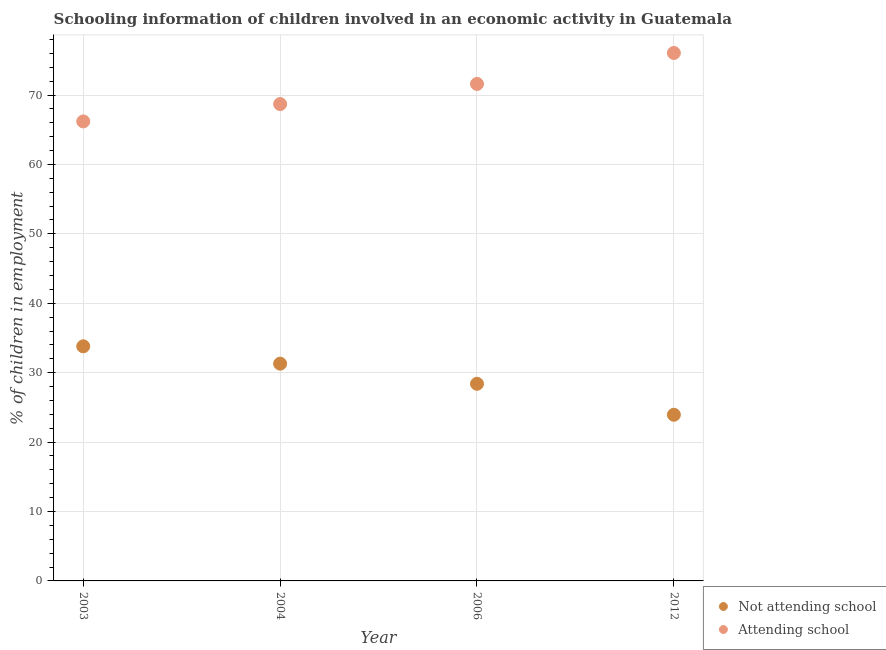How many different coloured dotlines are there?
Your answer should be compact. 2. Is the number of dotlines equal to the number of legend labels?
Keep it short and to the point. Yes. What is the percentage of employed children who are attending school in 2006?
Make the answer very short. 71.6. Across all years, what is the maximum percentage of employed children who are attending school?
Your answer should be compact. 76.06. Across all years, what is the minimum percentage of employed children who are attending school?
Your answer should be very brief. 66.2. In which year was the percentage of employed children who are attending school maximum?
Ensure brevity in your answer.  2012. What is the total percentage of employed children who are attending school in the graph?
Your response must be concise. 282.56. What is the difference between the percentage of employed children who are attending school in 2006 and the percentage of employed children who are not attending school in 2012?
Provide a short and direct response. 47.66. What is the average percentage of employed children who are attending school per year?
Make the answer very short. 70.64. In the year 2006, what is the difference between the percentage of employed children who are not attending school and percentage of employed children who are attending school?
Your answer should be very brief. -43.2. What is the ratio of the percentage of employed children who are attending school in 2003 to that in 2006?
Provide a short and direct response. 0.92. Is the percentage of employed children who are attending school in 2003 less than that in 2012?
Provide a short and direct response. Yes. Is the difference between the percentage of employed children who are not attending school in 2004 and 2012 greater than the difference between the percentage of employed children who are attending school in 2004 and 2012?
Offer a terse response. Yes. What is the difference between the highest and the second highest percentage of employed children who are not attending school?
Your response must be concise. 2.5. What is the difference between the highest and the lowest percentage of employed children who are attending school?
Your answer should be very brief. 9.86. In how many years, is the percentage of employed children who are not attending school greater than the average percentage of employed children who are not attending school taken over all years?
Provide a short and direct response. 2. Does the percentage of employed children who are attending school monotonically increase over the years?
Your answer should be compact. Yes. Is the percentage of employed children who are attending school strictly less than the percentage of employed children who are not attending school over the years?
Offer a very short reply. No. Does the graph contain any zero values?
Provide a succinct answer. No. Does the graph contain grids?
Your answer should be very brief. Yes. How are the legend labels stacked?
Your answer should be very brief. Vertical. What is the title of the graph?
Offer a terse response. Schooling information of children involved in an economic activity in Guatemala. What is the label or title of the X-axis?
Offer a terse response. Year. What is the label or title of the Y-axis?
Keep it short and to the point. % of children in employment. What is the % of children in employment in Not attending school in 2003?
Ensure brevity in your answer.  33.8. What is the % of children in employment of Attending school in 2003?
Give a very brief answer. 66.2. What is the % of children in employment in Not attending school in 2004?
Offer a very short reply. 31.3. What is the % of children in employment in Attending school in 2004?
Offer a very short reply. 68.7. What is the % of children in employment in Not attending school in 2006?
Ensure brevity in your answer.  28.4. What is the % of children in employment of Attending school in 2006?
Offer a very short reply. 71.6. What is the % of children in employment in Not attending school in 2012?
Provide a succinct answer. 23.94. What is the % of children in employment in Attending school in 2012?
Give a very brief answer. 76.06. Across all years, what is the maximum % of children in employment of Not attending school?
Give a very brief answer. 33.8. Across all years, what is the maximum % of children in employment of Attending school?
Ensure brevity in your answer.  76.06. Across all years, what is the minimum % of children in employment of Not attending school?
Provide a short and direct response. 23.94. Across all years, what is the minimum % of children in employment in Attending school?
Make the answer very short. 66.2. What is the total % of children in employment of Not attending school in the graph?
Keep it short and to the point. 117.44. What is the total % of children in employment in Attending school in the graph?
Provide a succinct answer. 282.56. What is the difference between the % of children in employment of Attending school in 2003 and that in 2006?
Provide a succinct answer. -5.4. What is the difference between the % of children in employment of Not attending school in 2003 and that in 2012?
Make the answer very short. 9.86. What is the difference between the % of children in employment in Attending school in 2003 and that in 2012?
Your answer should be compact. -9.86. What is the difference between the % of children in employment in Not attending school in 2004 and that in 2006?
Provide a short and direct response. 2.9. What is the difference between the % of children in employment in Attending school in 2004 and that in 2006?
Your response must be concise. -2.9. What is the difference between the % of children in employment of Not attending school in 2004 and that in 2012?
Provide a succinct answer. 7.36. What is the difference between the % of children in employment of Attending school in 2004 and that in 2012?
Your response must be concise. -7.36. What is the difference between the % of children in employment of Not attending school in 2006 and that in 2012?
Make the answer very short. 4.46. What is the difference between the % of children in employment of Attending school in 2006 and that in 2012?
Keep it short and to the point. -4.46. What is the difference between the % of children in employment in Not attending school in 2003 and the % of children in employment in Attending school in 2004?
Ensure brevity in your answer.  -34.9. What is the difference between the % of children in employment of Not attending school in 2003 and the % of children in employment of Attending school in 2006?
Offer a terse response. -37.8. What is the difference between the % of children in employment of Not attending school in 2003 and the % of children in employment of Attending school in 2012?
Your answer should be compact. -42.26. What is the difference between the % of children in employment of Not attending school in 2004 and the % of children in employment of Attending school in 2006?
Provide a succinct answer. -40.3. What is the difference between the % of children in employment in Not attending school in 2004 and the % of children in employment in Attending school in 2012?
Your answer should be very brief. -44.76. What is the difference between the % of children in employment in Not attending school in 2006 and the % of children in employment in Attending school in 2012?
Make the answer very short. -47.66. What is the average % of children in employment of Not attending school per year?
Provide a short and direct response. 29.36. What is the average % of children in employment of Attending school per year?
Ensure brevity in your answer.  70.64. In the year 2003, what is the difference between the % of children in employment in Not attending school and % of children in employment in Attending school?
Give a very brief answer. -32.4. In the year 2004, what is the difference between the % of children in employment of Not attending school and % of children in employment of Attending school?
Make the answer very short. -37.4. In the year 2006, what is the difference between the % of children in employment in Not attending school and % of children in employment in Attending school?
Ensure brevity in your answer.  -43.2. In the year 2012, what is the difference between the % of children in employment in Not attending school and % of children in employment in Attending school?
Give a very brief answer. -52.12. What is the ratio of the % of children in employment of Not attending school in 2003 to that in 2004?
Offer a very short reply. 1.08. What is the ratio of the % of children in employment in Attending school in 2003 to that in 2004?
Offer a terse response. 0.96. What is the ratio of the % of children in employment of Not attending school in 2003 to that in 2006?
Offer a very short reply. 1.19. What is the ratio of the % of children in employment in Attending school in 2003 to that in 2006?
Your answer should be compact. 0.92. What is the ratio of the % of children in employment of Not attending school in 2003 to that in 2012?
Give a very brief answer. 1.41. What is the ratio of the % of children in employment of Attending school in 2003 to that in 2012?
Your answer should be compact. 0.87. What is the ratio of the % of children in employment of Not attending school in 2004 to that in 2006?
Provide a succinct answer. 1.1. What is the ratio of the % of children in employment of Attending school in 2004 to that in 2006?
Keep it short and to the point. 0.96. What is the ratio of the % of children in employment in Not attending school in 2004 to that in 2012?
Provide a succinct answer. 1.31. What is the ratio of the % of children in employment in Attending school in 2004 to that in 2012?
Make the answer very short. 0.9. What is the ratio of the % of children in employment in Not attending school in 2006 to that in 2012?
Offer a very short reply. 1.19. What is the ratio of the % of children in employment of Attending school in 2006 to that in 2012?
Your answer should be very brief. 0.94. What is the difference between the highest and the second highest % of children in employment of Not attending school?
Give a very brief answer. 2.5. What is the difference between the highest and the second highest % of children in employment in Attending school?
Your answer should be compact. 4.46. What is the difference between the highest and the lowest % of children in employment in Not attending school?
Ensure brevity in your answer.  9.86. What is the difference between the highest and the lowest % of children in employment of Attending school?
Your answer should be very brief. 9.86. 